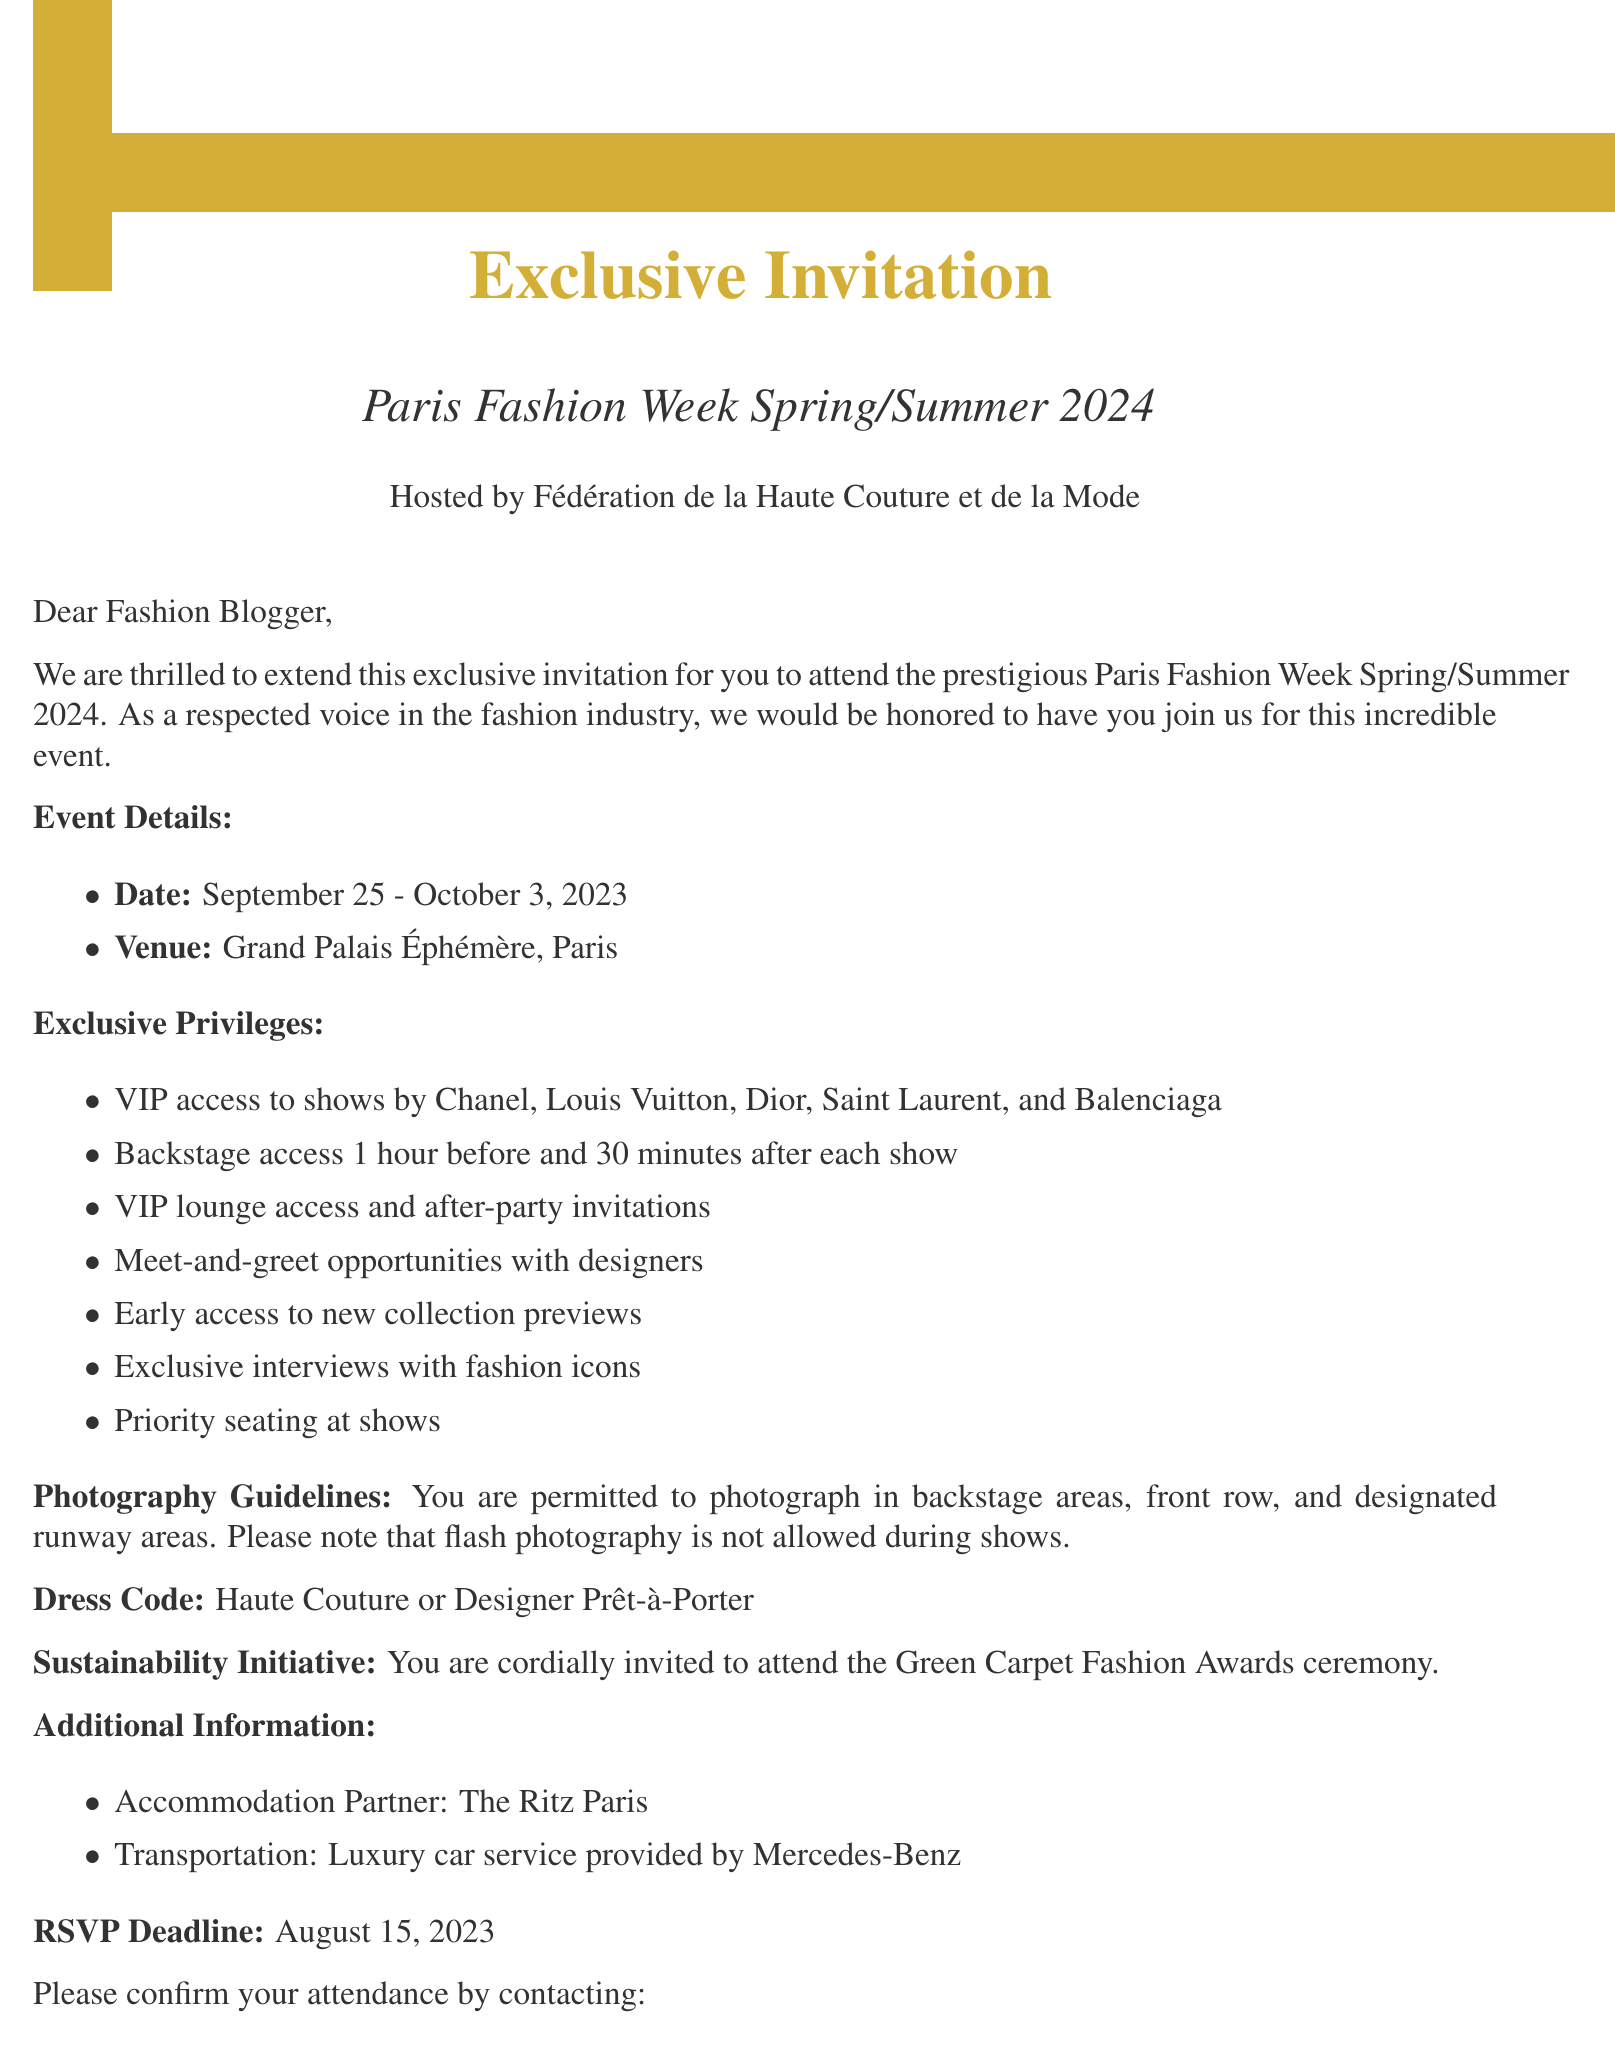What is the name of the event? The name of the event is mentioned prominently in the invitation as "Paris Fashion Week Spring/Summer 2024."
Answer: Paris Fashion Week Spring/Summer 2024 Who is hosting the event? The host of the event is stated clearly in the document.
Answer: Fédération de la Haute Couture et de la Mode What are the dates of the event? The specific dates of the event are provided for attendees to take note of.
Answer: September 25 - October 3, 2023 Which designers' shows are invited? A list of designers whose shows are part of the invitation is provided.
Answer: Chanel, Louis Vuitton, Dior, Saint Laurent, Balenciaga What is the dress code for the event? The document specifies the required attire for attendees.
Answer: Haute Couture or Designer Prêt-à-Porter What is the RSVP deadline? The deadline for confirming attendance is highlighted in the invitation.
Answer: August 15, 2023 Who is the contact person for the event? The invitation lists a contact person for any inquiries related to the event.
Answer: Sophie Durand What is one of the special privileges mentioned? The document lists various special privileges available to the invitee.
Answer: Early access to new collection previews Where is the venue for the event? The venue where the event will take place is specified in the document.
Answer: Grand Palais Éphémère, Paris What type of transportation is provided? The type of transportation mentioned in the additional information section is specified.
Answer: Luxury car service provided by Mercedes-Benz 